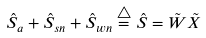Convert formula to latex. <formula><loc_0><loc_0><loc_500><loc_500>\hat { S } _ { a } + \hat { S } _ { s n } + \hat { S } _ { w n } \overset { \triangle } { = } \hat { S } = \tilde { W } \tilde { X }</formula> 